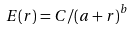Convert formula to latex. <formula><loc_0><loc_0><loc_500><loc_500>E ( r ) = C / { ( a + r ) } ^ { b }</formula> 